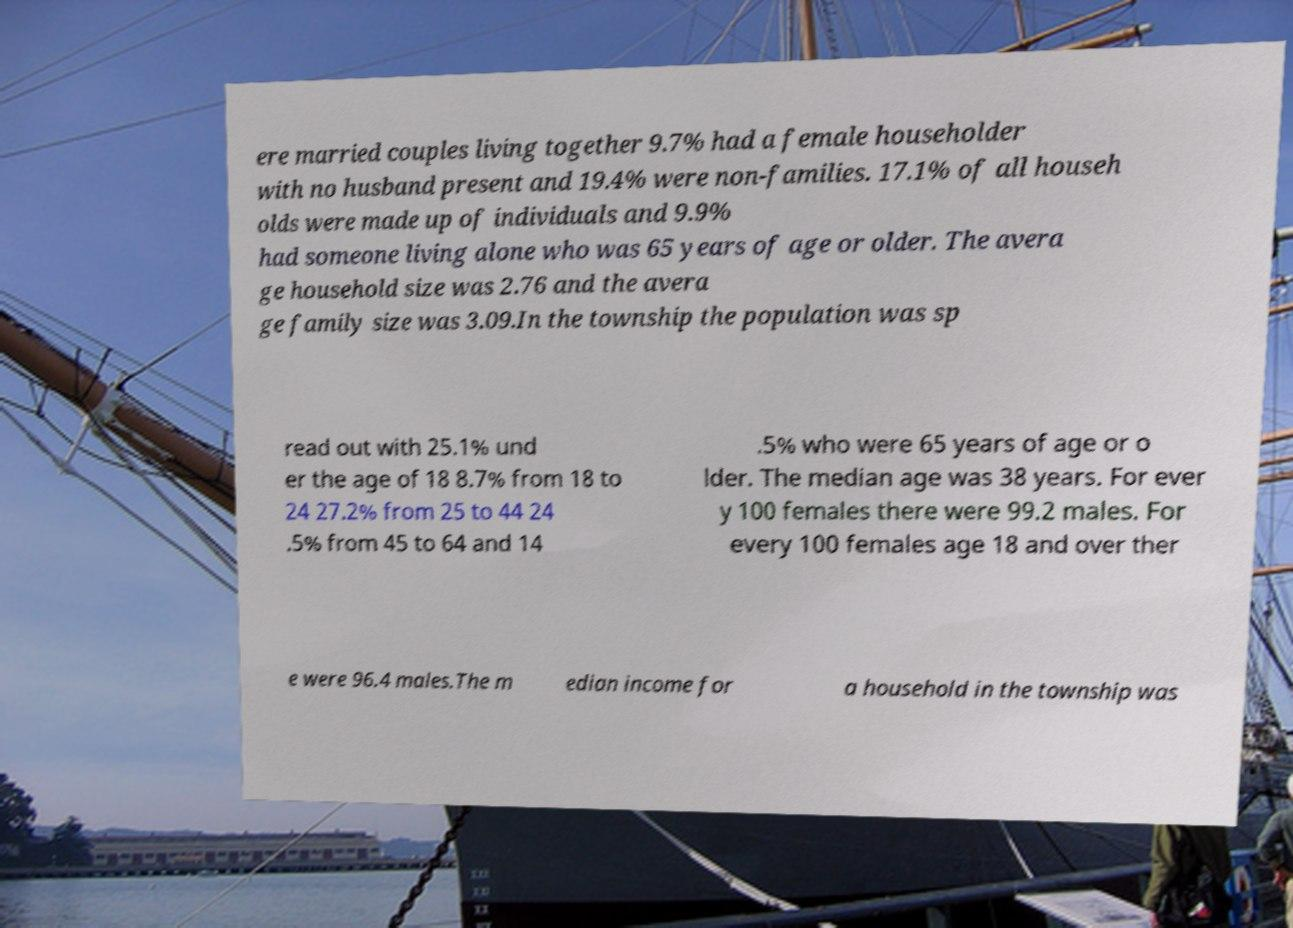Could you extract and type out the text from this image? ere married couples living together 9.7% had a female householder with no husband present and 19.4% were non-families. 17.1% of all househ olds were made up of individuals and 9.9% had someone living alone who was 65 years of age or older. The avera ge household size was 2.76 and the avera ge family size was 3.09.In the township the population was sp read out with 25.1% und er the age of 18 8.7% from 18 to 24 27.2% from 25 to 44 24 .5% from 45 to 64 and 14 .5% who were 65 years of age or o lder. The median age was 38 years. For ever y 100 females there were 99.2 males. For every 100 females age 18 and over ther e were 96.4 males.The m edian income for a household in the township was 